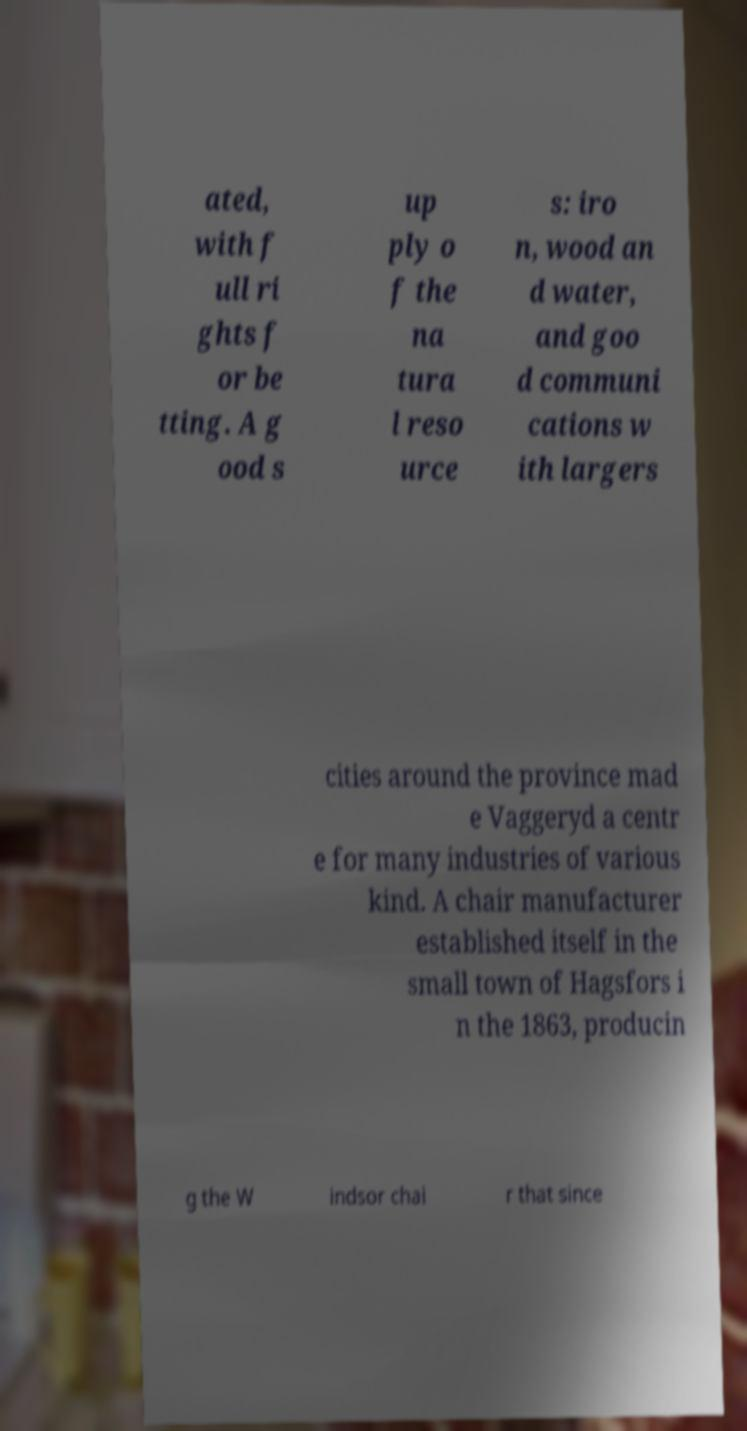For documentation purposes, I need the text within this image transcribed. Could you provide that? ated, with f ull ri ghts f or be tting. A g ood s up ply o f the na tura l reso urce s: iro n, wood an d water, and goo d communi cations w ith largers cities around the province mad e Vaggeryd a centr e for many industries of various kind. A chair manufacturer established itself in the small town of Hagsfors i n the 1863, producin g the W indsor chai r that since 